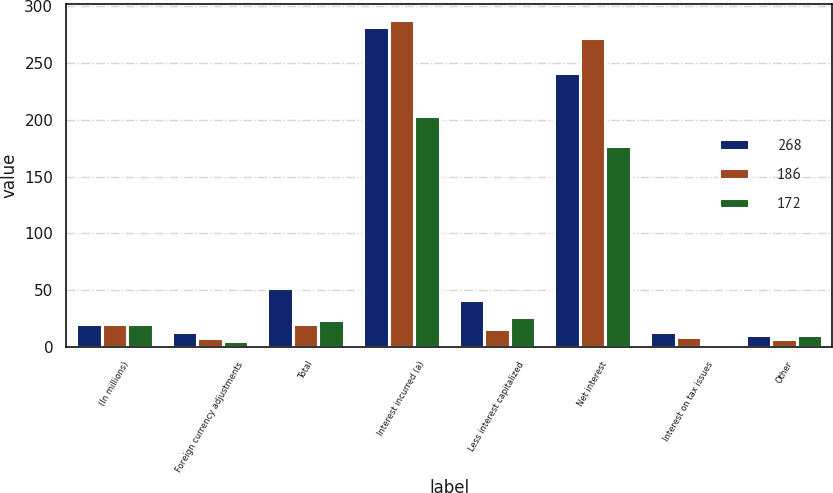Convert chart. <chart><loc_0><loc_0><loc_500><loc_500><stacked_bar_chart><ecel><fcel>(In millions)<fcel>Foreign currency adjustments<fcel>Total<fcel>Interest incurred (a)<fcel>Less interest capitalized<fcel>Net interest<fcel>Interest on tax issues<fcel>Other<nl><fcel>268<fcel>20<fcel>13<fcel>52<fcel>282<fcel>41<fcel>241<fcel>13<fcel>10<nl><fcel>186<fcel>20<fcel>8<fcel>20<fcel>288<fcel>16<fcel>272<fcel>9<fcel>7<nl><fcel>172<fcel>20<fcel>5<fcel>24<fcel>203<fcel>26<fcel>177<fcel>2<fcel>10<nl></chart> 